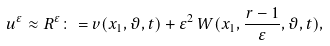<formula> <loc_0><loc_0><loc_500><loc_500>{ u } ^ { \varepsilon } \approx { R } ^ { \varepsilon } \colon = { v } ( x _ { 1 } , \vartheta , t ) + { \varepsilon ^ { 2 } } \, { W } ( x _ { 1 } , \frac { r - 1 } { \varepsilon } , \vartheta , t ) ,</formula> 